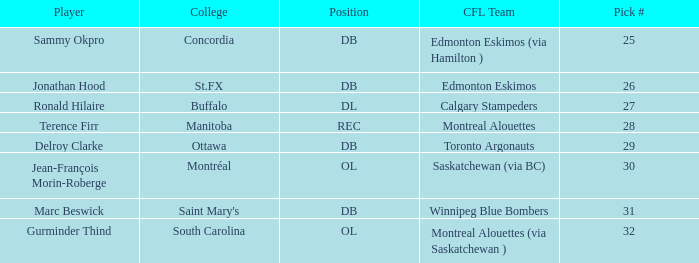Can you give me this table as a dict? {'header': ['Player', 'College', 'Position', 'CFL Team', 'Pick #'], 'rows': [['Sammy Okpro', 'Concordia', 'DB', 'Edmonton Eskimos (via Hamilton )', '25'], ['Jonathan Hood', 'St.FX', 'DB', 'Edmonton Eskimos', '26'], ['Ronald Hilaire', 'Buffalo', 'DL', 'Calgary Stampeders', '27'], ['Terence Firr', 'Manitoba', 'REC', 'Montreal Alouettes', '28'], ['Delroy Clarke', 'Ottawa', 'DB', 'Toronto Argonauts', '29'], ['Jean-François Morin-Roberge', 'Montréal', 'OL', 'Saskatchewan (via BC)', '30'], ['Marc Beswick', "Saint Mary's", 'DB', 'Winnipeg Blue Bombers', '31'], ['Gurminder Thind', 'South Carolina', 'OL', 'Montreal Alouettes (via Saskatchewan )', '32']]} Which Pick # has a College of concordia? 25.0. 